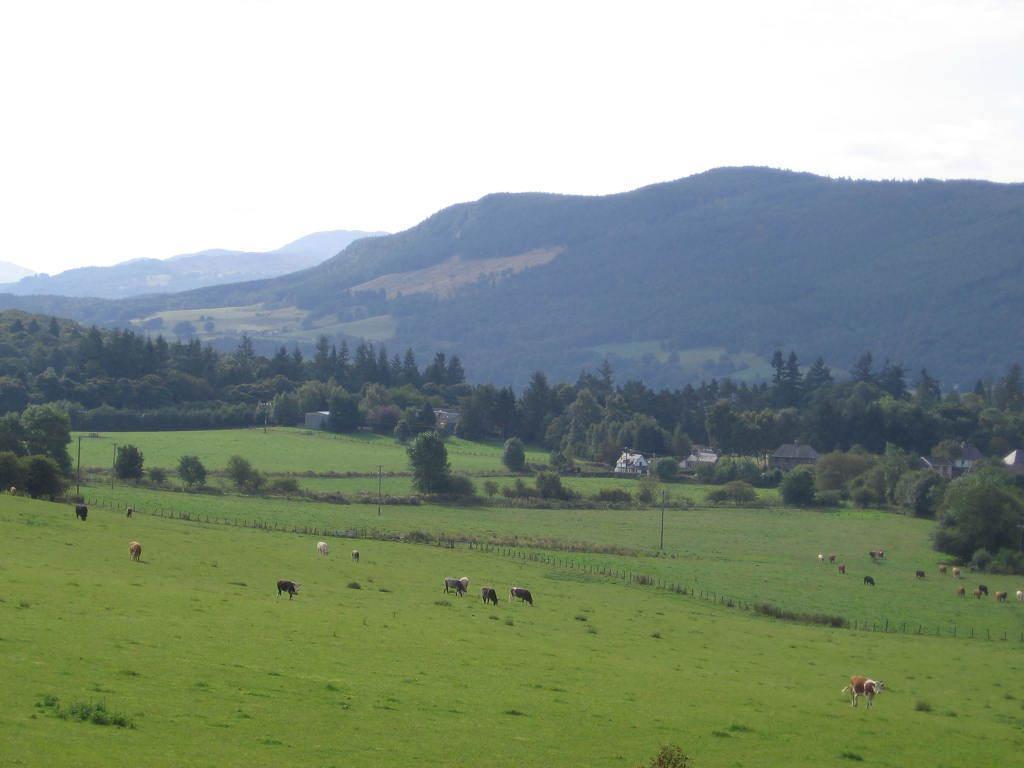Describe this image in one or two sentences. In this image in the front there's grass on the ground. In the center there are animals. In the background there are trees and mountains and there are houses. 